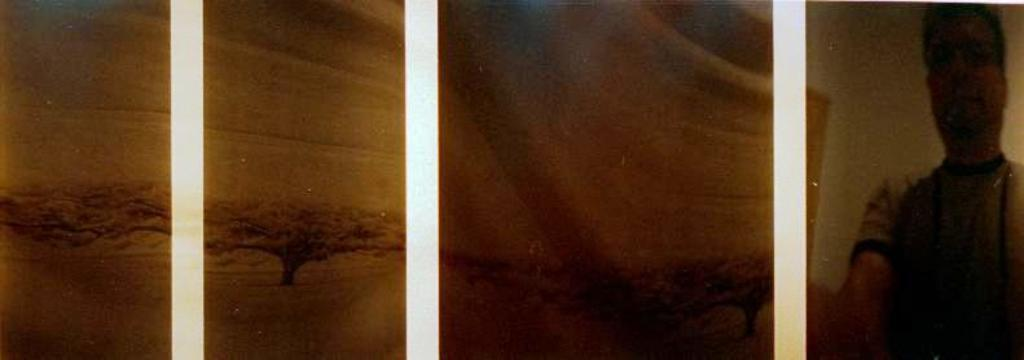What type of image is being described? The image is a collage. Can you identify any living beings in the image? Yes, there is a person in the image. What natural element is present in the image? There is a tree in the image. What color is the background of the image? The background of the image is cream-colored. How many books are being kicked by the person in the image? There are no books or kicking action present in the image. 